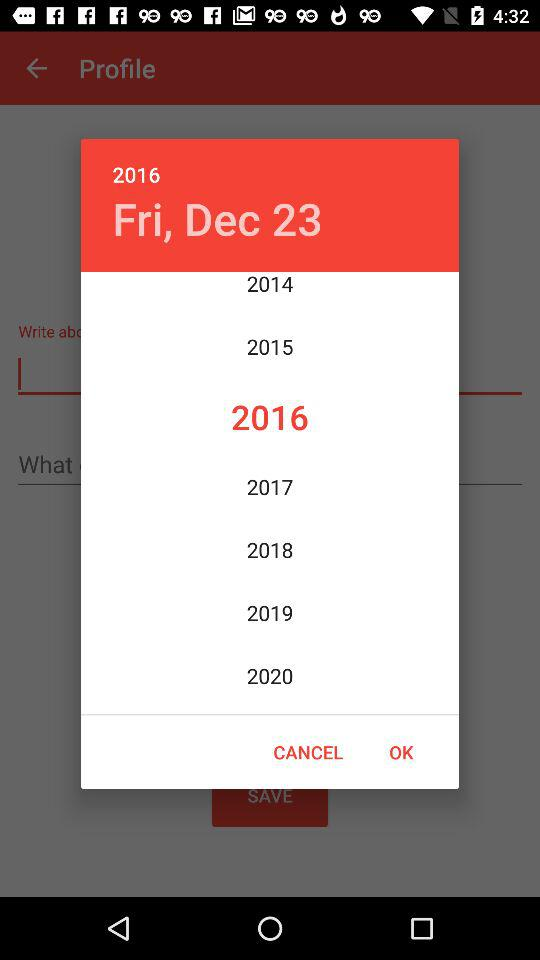What is the day on December 23? The day is Friday. 